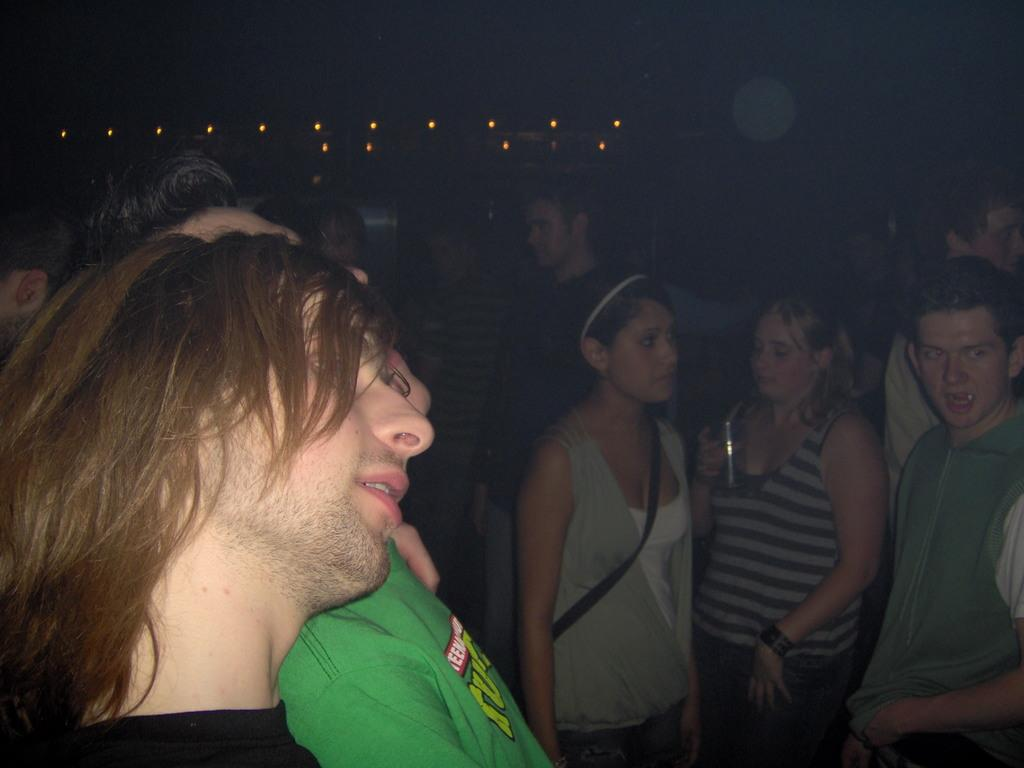How many people are in the image? There is a group of people in the image. What are the people in the image doing? The people are standing. What can be observed about the background of the image? The background of the image is dark. What type of scent can be detected from the island in the image? There is no island present in the image, so it is not possible to detect a scent from an island. 